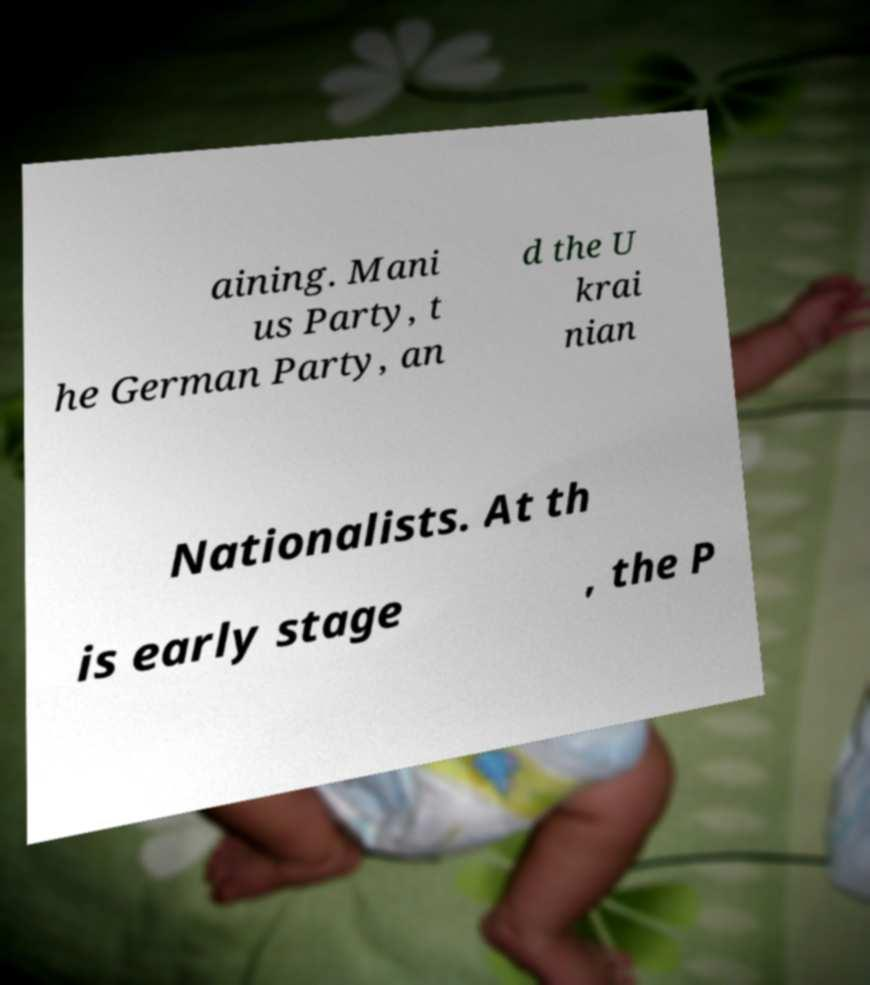Please identify and transcribe the text found in this image. aining. Mani us Party, t he German Party, an d the U krai nian Nationalists. At th is early stage , the P 